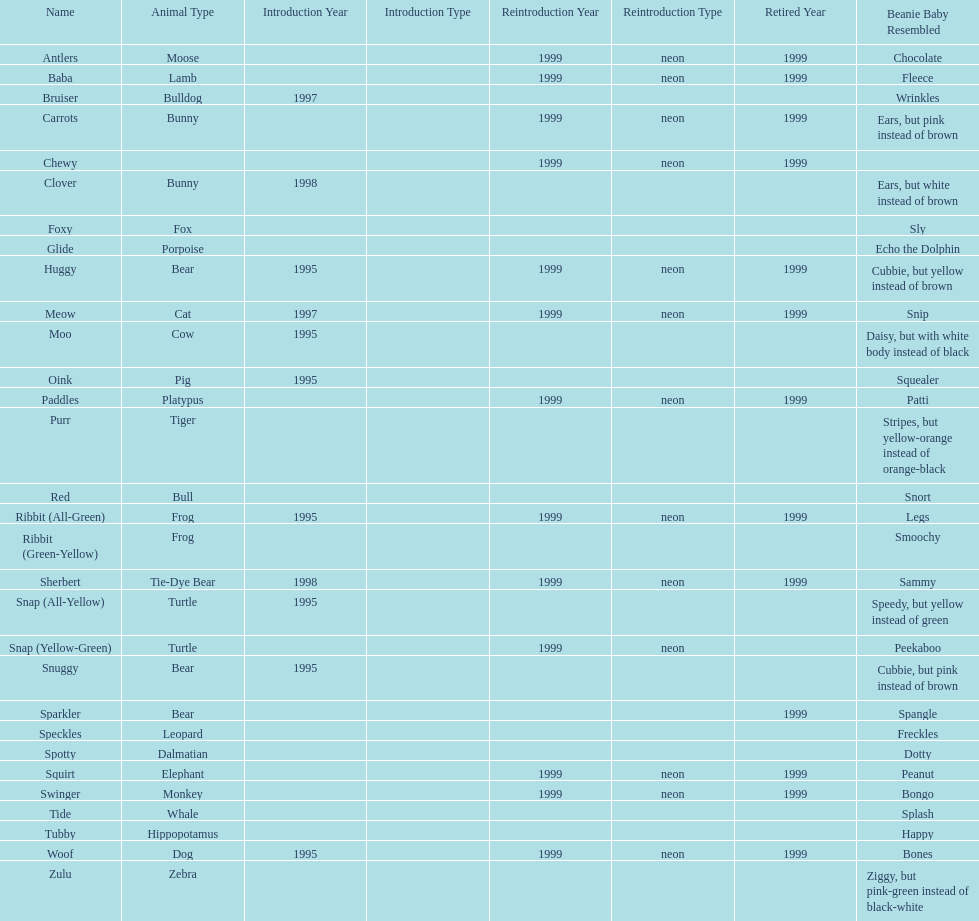Which is the only pillow pal without a listed animal type? Chewy. 